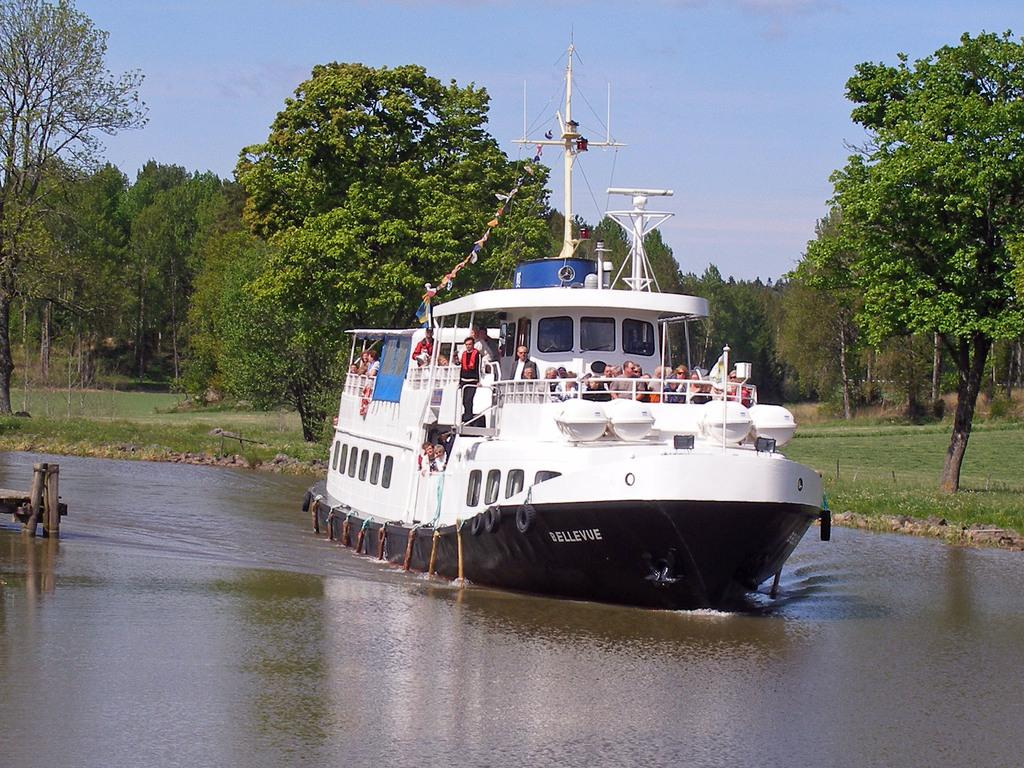What is the main subject of the image? There are people on a boat in the image. What can be seen in the background of the image? There is water, grass, trees, and the sky visible in the image. What type of environment is depicted in the image? The image shows a natural environment with water, grass, trees, and the sky. What type of reaction can be seen between the people on the boat in the image? There is no specific reaction visible between the people on the boat in the image. What symbol of peace is present in the image? There is no specific symbol of peace present in the image. 